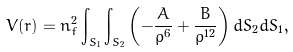Convert formula to latex. <formula><loc_0><loc_0><loc_500><loc_500>V ( r ) = n _ { f } ^ { 2 } \int _ { S _ { 1 } } \int _ { S _ { 2 } } \left ( - \frac { A } { \rho ^ { 6 } } + \frac { B } { \rho ^ { 1 2 } } \right ) d S _ { 2 } d S _ { 1 } ,</formula> 